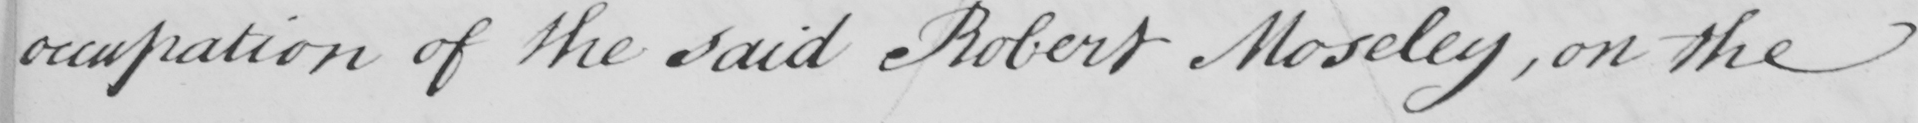What text is written in this handwritten line? occupation of the said Robert Moseley , on the 